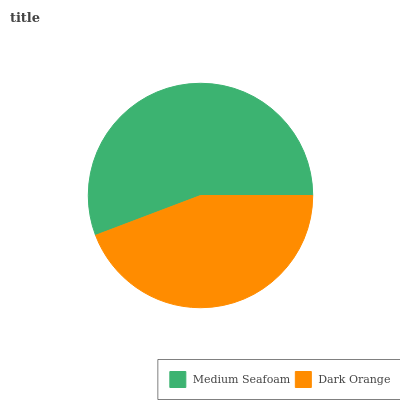Is Dark Orange the minimum?
Answer yes or no. Yes. Is Medium Seafoam the maximum?
Answer yes or no. Yes. Is Dark Orange the maximum?
Answer yes or no. No. Is Medium Seafoam greater than Dark Orange?
Answer yes or no. Yes. Is Dark Orange less than Medium Seafoam?
Answer yes or no. Yes. Is Dark Orange greater than Medium Seafoam?
Answer yes or no. No. Is Medium Seafoam less than Dark Orange?
Answer yes or no. No. Is Medium Seafoam the high median?
Answer yes or no. Yes. Is Dark Orange the low median?
Answer yes or no. Yes. Is Dark Orange the high median?
Answer yes or no. No. Is Medium Seafoam the low median?
Answer yes or no. No. 